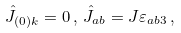Convert formula to latex. <formula><loc_0><loc_0><loc_500><loc_500>\hat { J } _ { ( 0 ) k } = 0 \, , \, \hat { J } _ { a b } = J { \varepsilon } _ { a b 3 } \, ,</formula> 